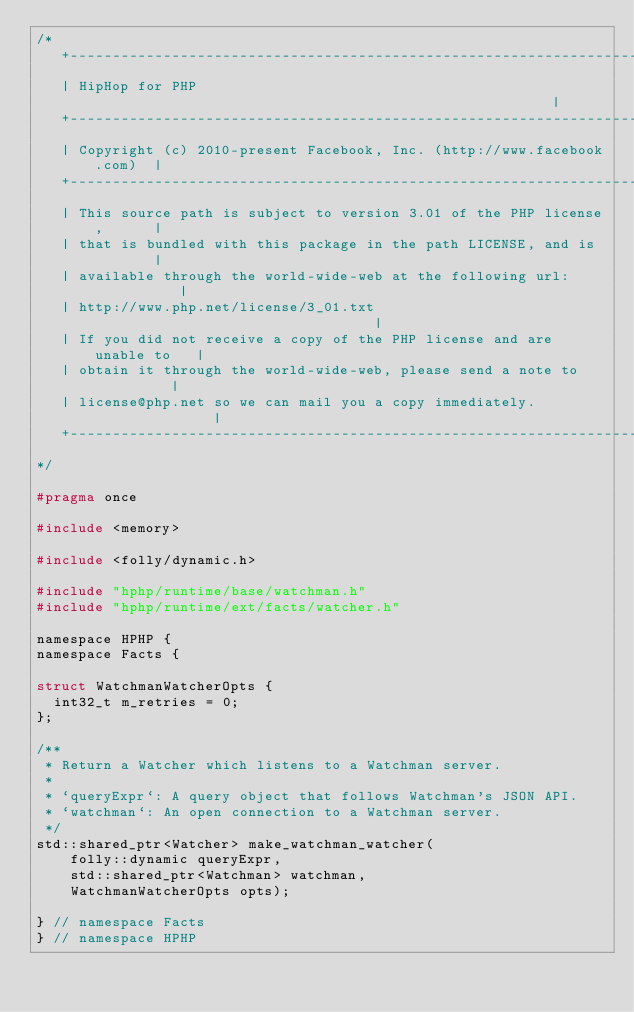<code> <loc_0><loc_0><loc_500><loc_500><_C_>/*
   +----------------------------------------------------------------------+
   | HipHop for PHP                                                       |
   +----------------------------------------------------------------------+
   | Copyright (c) 2010-present Facebook, Inc. (http://www.facebook.com)  |
   +----------------------------------------------------------------------+
   | This source path is subject to version 3.01 of the PHP license,      |
   | that is bundled with this package in the path LICENSE, and is        |
   | available through the world-wide-web at the following url:           |
   | http://www.php.net/license/3_01.txt                                  |
   | If you did not receive a copy of the PHP license and are unable to   |
   | obtain it through the world-wide-web, please send a note to          |
   | license@php.net so we can mail you a copy immediately.               |
   +----------------------------------------------------------------------+
*/

#pragma once

#include <memory>

#include <folly/dynamic.h>

#include "hphp/runtime/base/watchman.h"
#include "hphp/runtime/ext/facts/watcher.h"

namespace HPHP {
namespace Facts {

struct WatchmanWatcherOpts {
  int32_t m_retries = 0;
};

/**
 * Return a Watcher which listens to a Watchman server.
 *
 * `queryExpr`: A query object that follows Watchman's JSON API.
 * `watchman`: An open connection to a Watchman server.
 */
std::shared_ptr<Watcher> make_watchman_watcher(
    folly::dynamic queryExpr,
    std::shared_ptr<Watchman> watchman,
    WatchmanWatcherOpts opts);

} // namespace Facts
} // namespace HPHP
</code> 